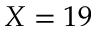Convert formula to latex. <formula><loc_0><loc_0><loc_500><loc_500>X = 1 9</formula> 